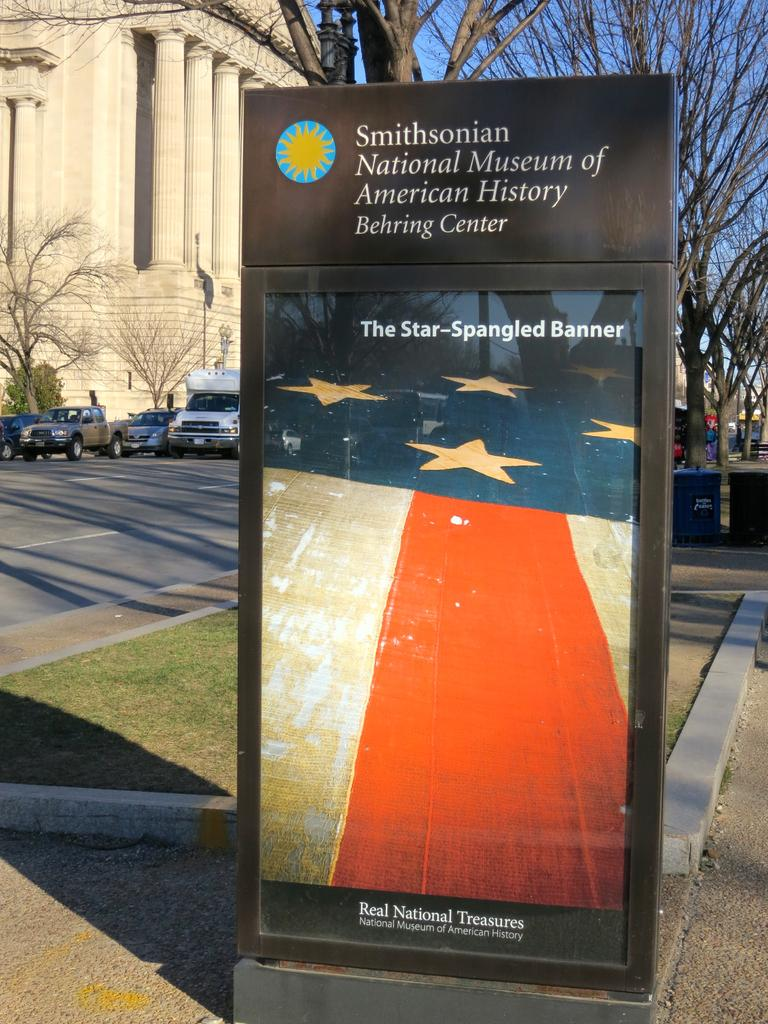<image>
Write a terse but informative summary of the picture. a sign with the word Smithsonian at the top of it 